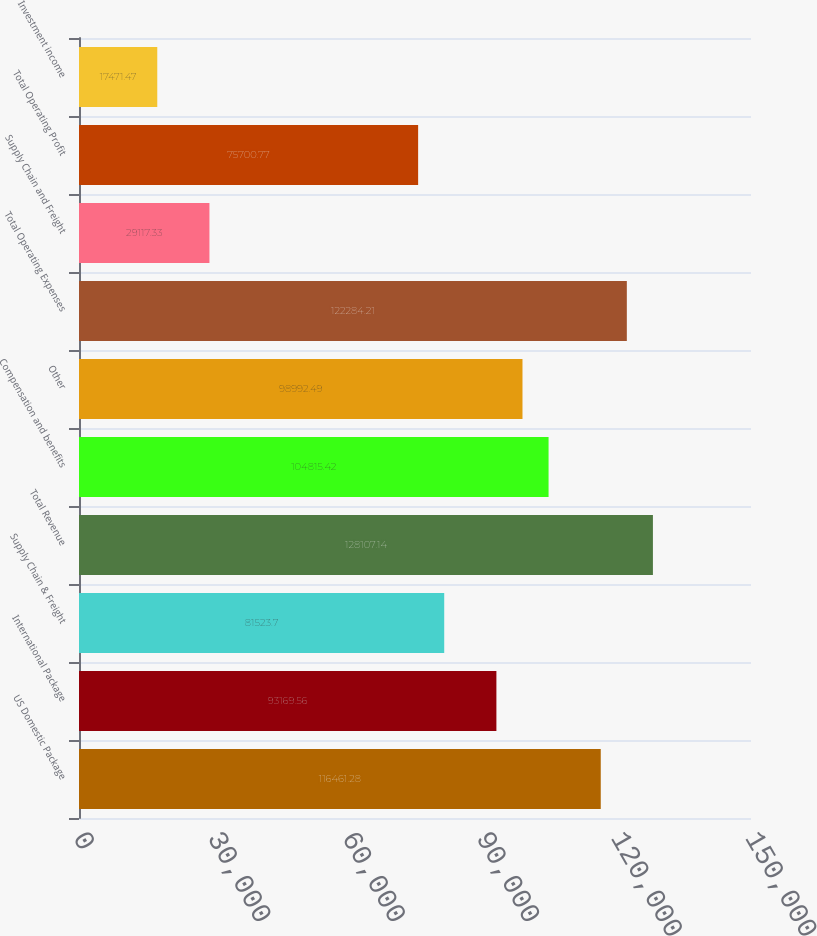<chart> <loc_0><loc_0><loc_500><loc_500><bar_chart><fcel>US Domestic Package<fcel>International Package<fcel>Supply Chain & Freight<fcel>Total Revenue<fcel>Compensation and benefits<fcel>Other<fcel>Total Operating Expenses<fcel>Supply Chain and Freight<fcel>Total Operating Profit<fcel>Investment income<nl><fcel>116461<fcel>93169.6<fcel>81523.7<fcel>128107<fcel>104815<fcel>98992.5<fcel>122284<fcel>29117.3<fcel>75700.8<fcel>17471.5<nl></chart> 